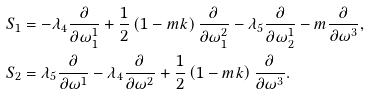<formula> <loc_0><loc_0><loc_500><loc_500>S _ { 1 } & = - { \lambda } _ { 4 } \frac { \partial } { \partial \omega ^ { 1 } _ { 1 } } + \frac { 1 } { 2 } \left ( 1 - m k \right ) \frac { \partial } { \partial \omega ^ { 2 } _ { 1 } } - { \lambda } _ { 5 } \frac { \partial } { \partial \omega ^ { 1 } _ { 2 } } - m \frac { \partial } { \partial \omega ^ { 3 } } , \\ S _ { 2 } & = { \lambda } _ { 5 } \frac { \partial } { \partial \omega ^ { 1 } } - { \lambda } _ { 4 } \frac { \partial } { \partial \omega ^ { 2 } } + \frac { 1 } { 2 } \left ( 1 - m k \right ) \frac { \partial } { \partial \omega ^ { 3 } } .</formula> 